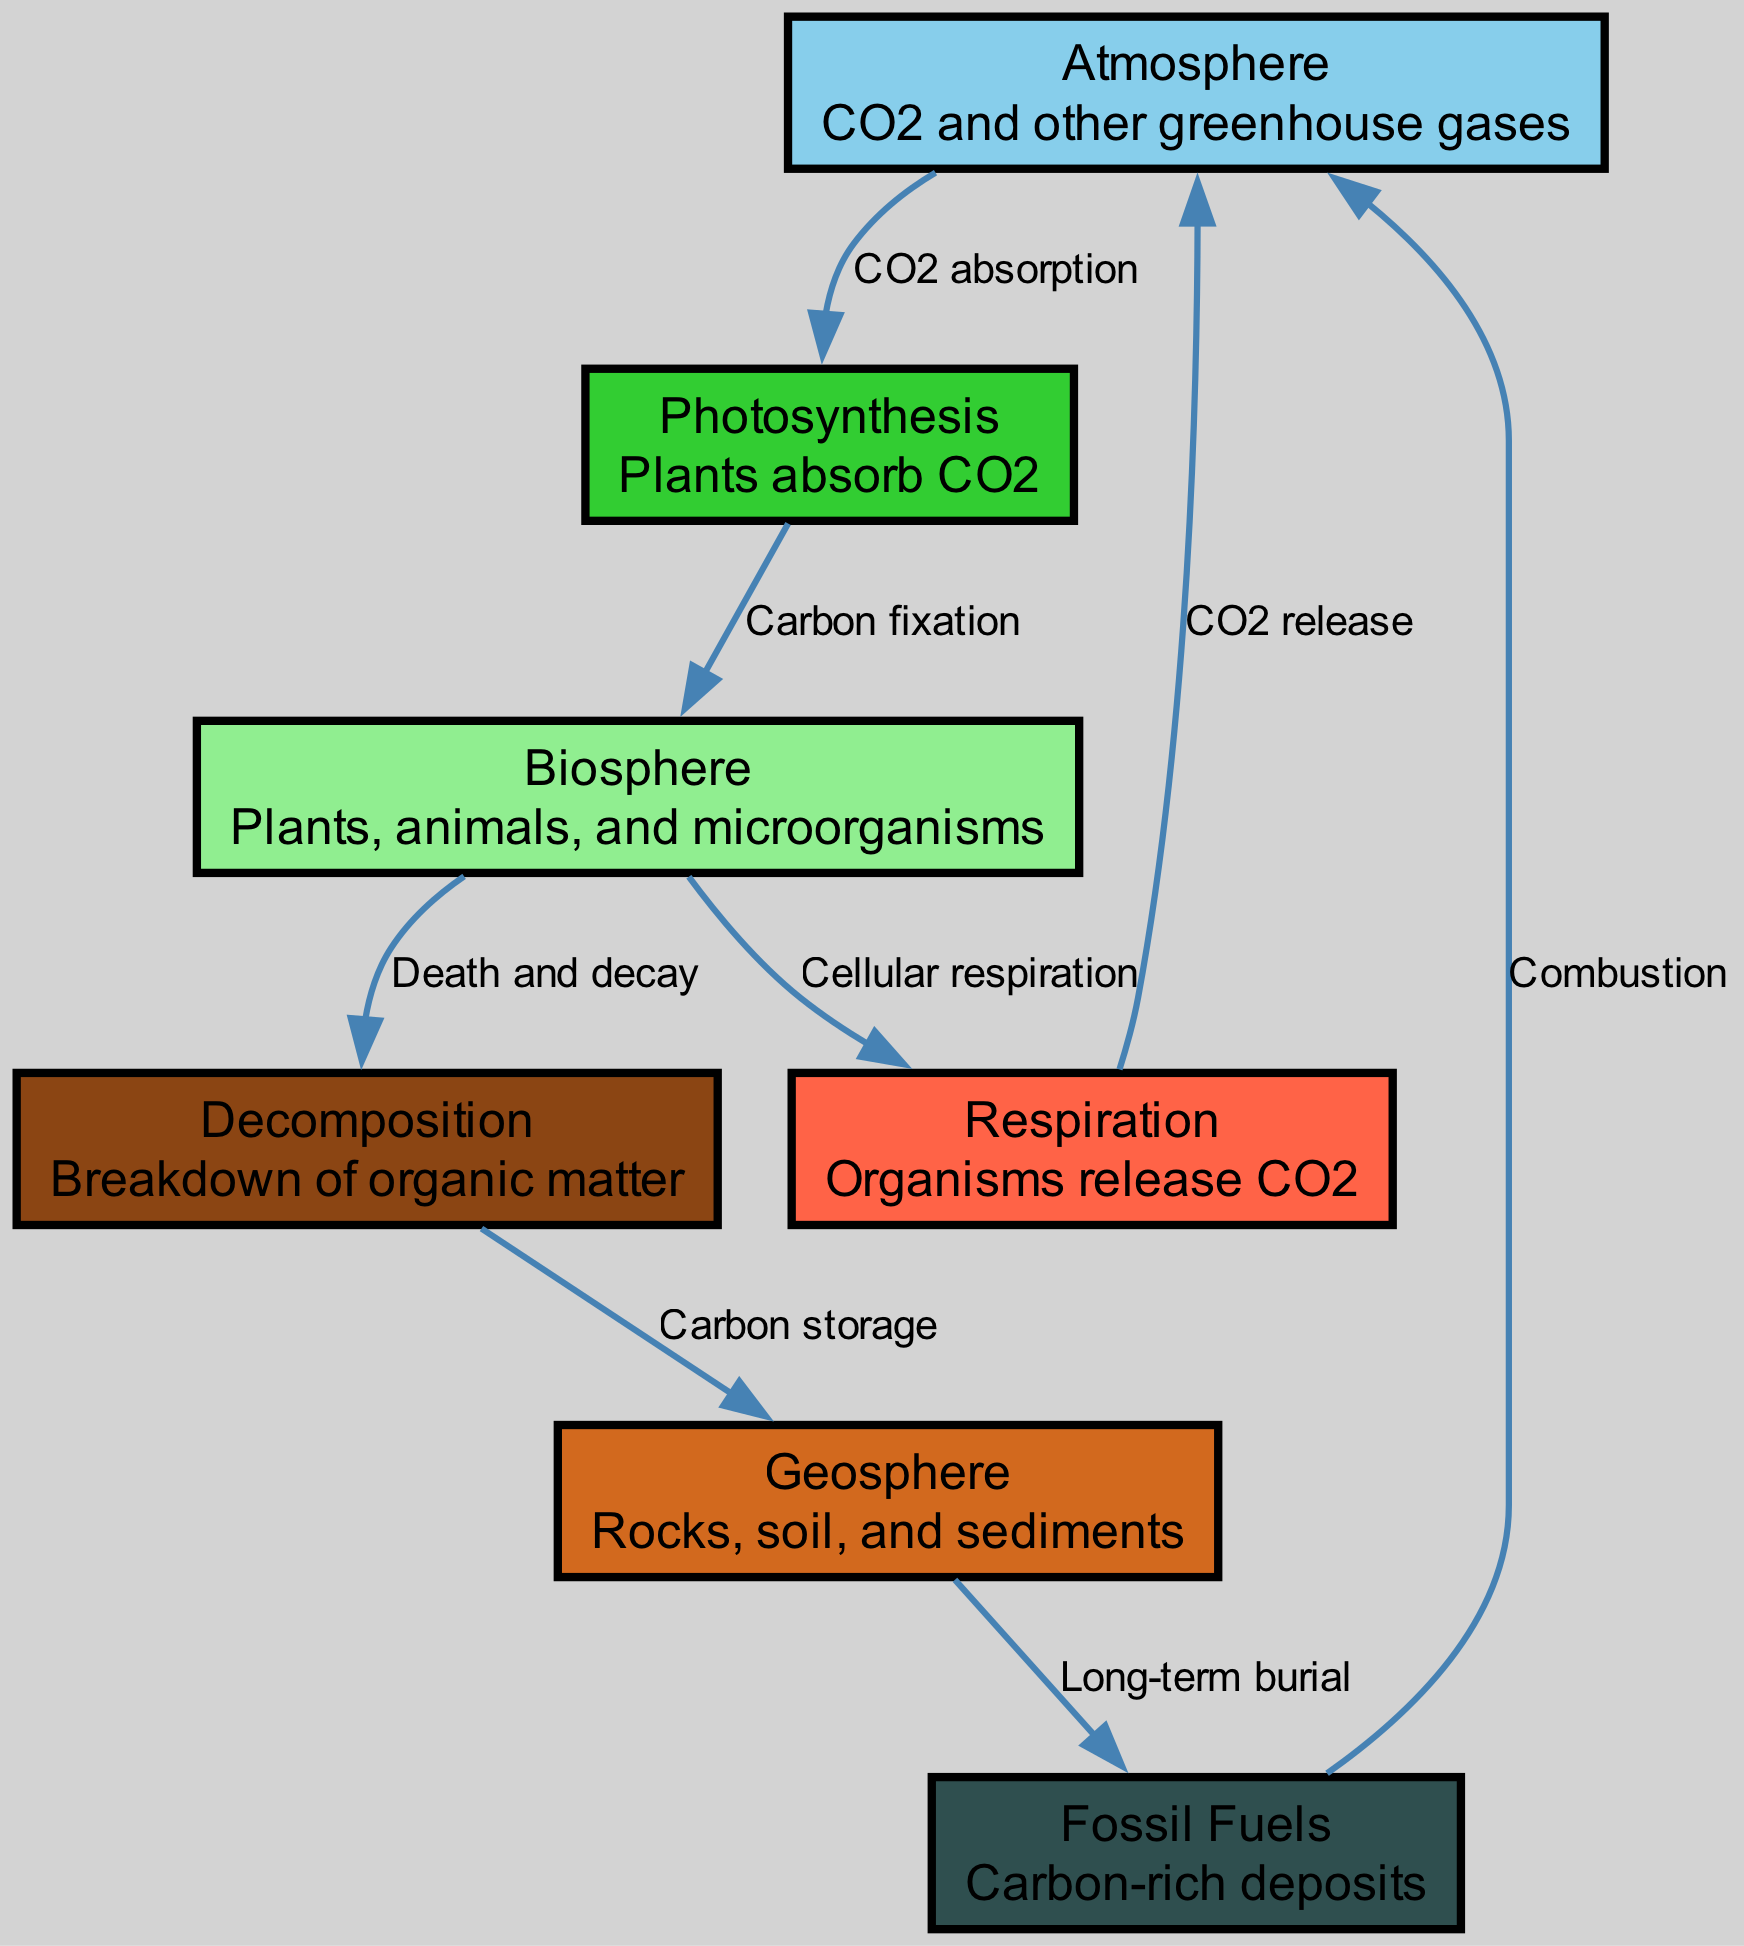What are the three major components of the carbon cycle shown in the diagram? The diagram includes three major components: Atmosphere, Biosphere, and Geosphere, which are represented as nodes.
Answer: Atmosphere, Biosphere, Geosphere How many edges connect the atmosphere to other nodes? There are four edges originating from the Atmosphere node, connecting it to Photosynthesis, Respiration, and Fossil Fuels.
Answer: 4 What process allows CO2 to be absorbed by plants? The process is mentioned in the diagram as Photosynthesis, where plants absorb CO2 from the atmosphere.
Answer: Photosynthesis Which process describes the release of CO2 by organisms in the biosphere? The diagram indicates that Respiration is the process through which organisms release CO2 back into the atmosphere.
Answer: Respiration What is the final destination of carbon after long-term burial in the geosphere? The carbon is ultimately stored in Fossil Fuels as indicated by the connection from Geosphere to Fossil Fuels through the Long-term burial process.
Answer: Fossil Fuels How does atmospheric carbon re-enter the atmosphere after being part of the biosphere? The process is through Respiration, which connects the Biosphere back to the Atmosphere, resulting in CO2 release.
Answer: Respiration What is the relationship between decomposition and geosphere in the carbon cycle? The diagram shows that Decomposition leads to Carbon storage in the Geosphere, indicating a flow of carbon from organic matter breakdown to storage in rocks and sediments.
Answer: Carbon storage How do fossil fuels return carbon to the atmosphere? This occurs through the process labeled Combustion, where fossil fuels are burned, releasing carbon back into the atmosphere.
Answer: Combustion 